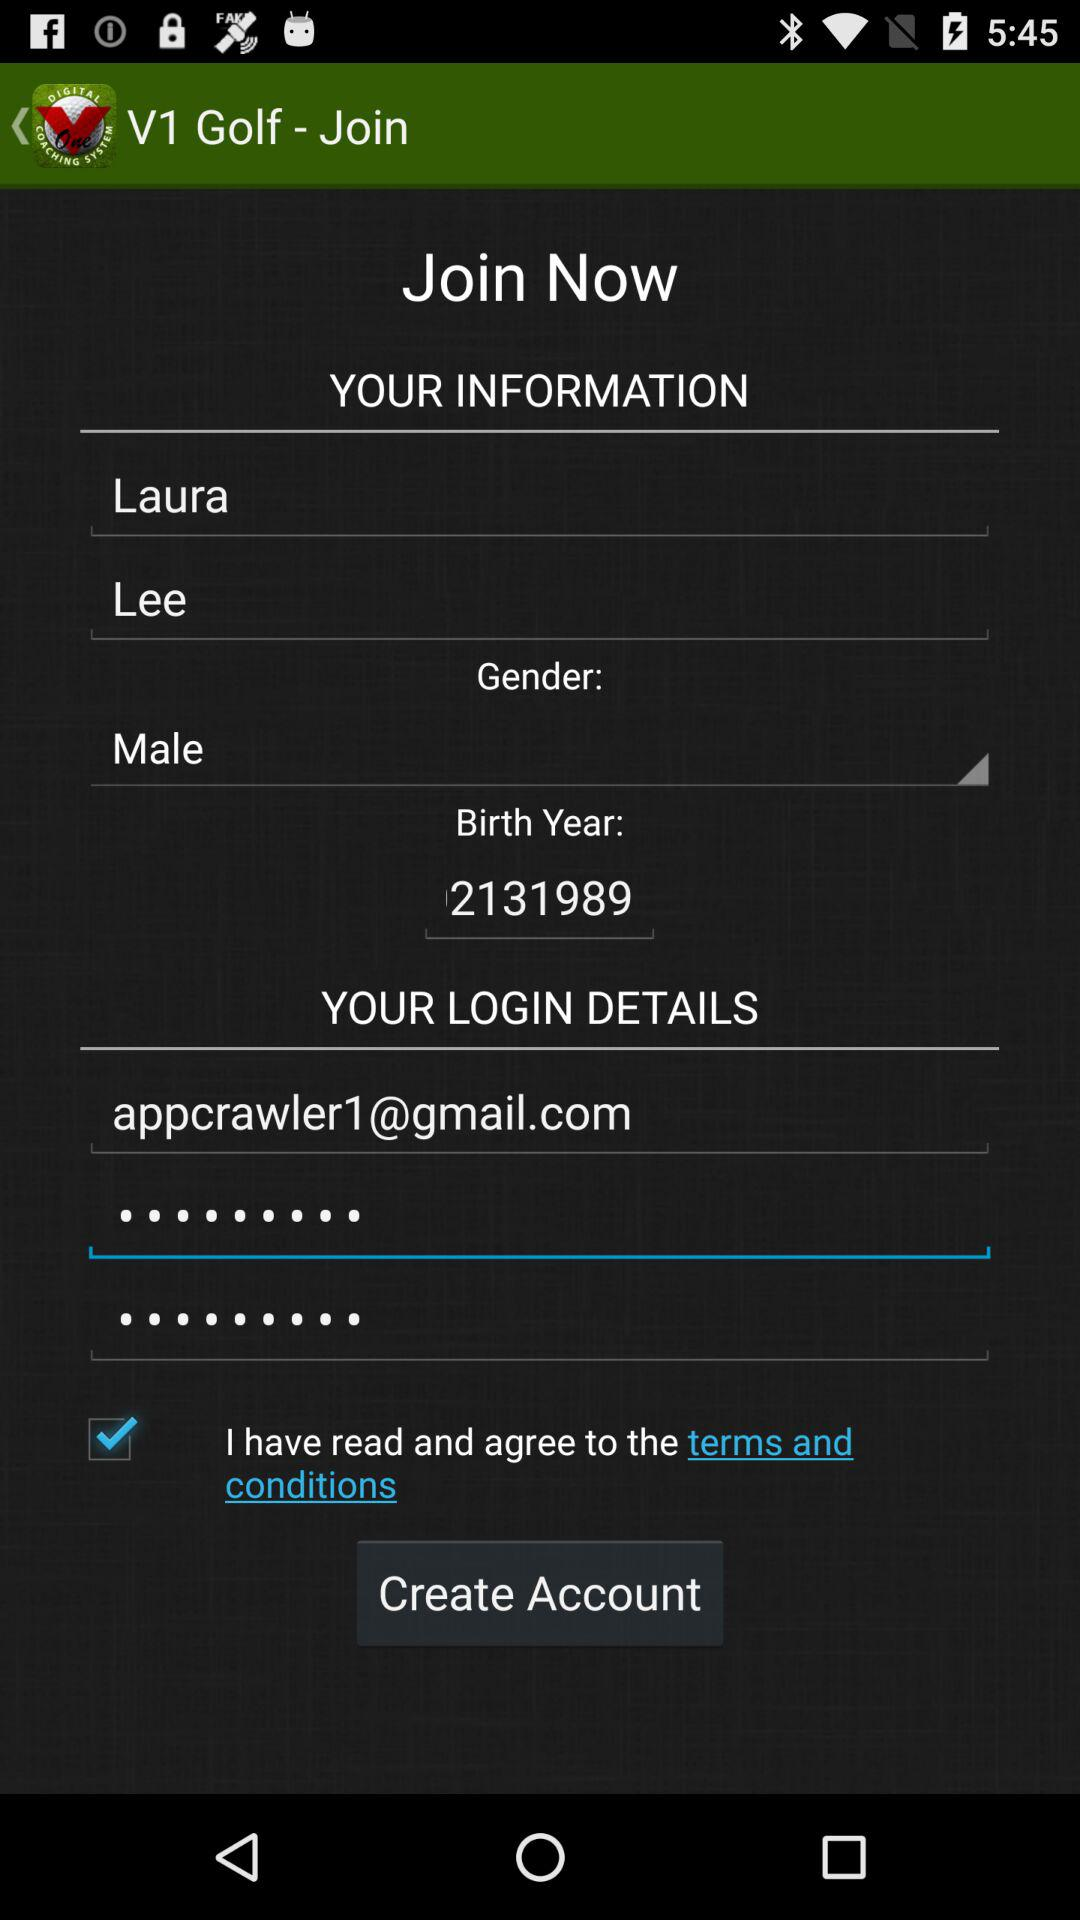What is the status of the option that includes agreement to the "terms and conditions"? The status is "on". 